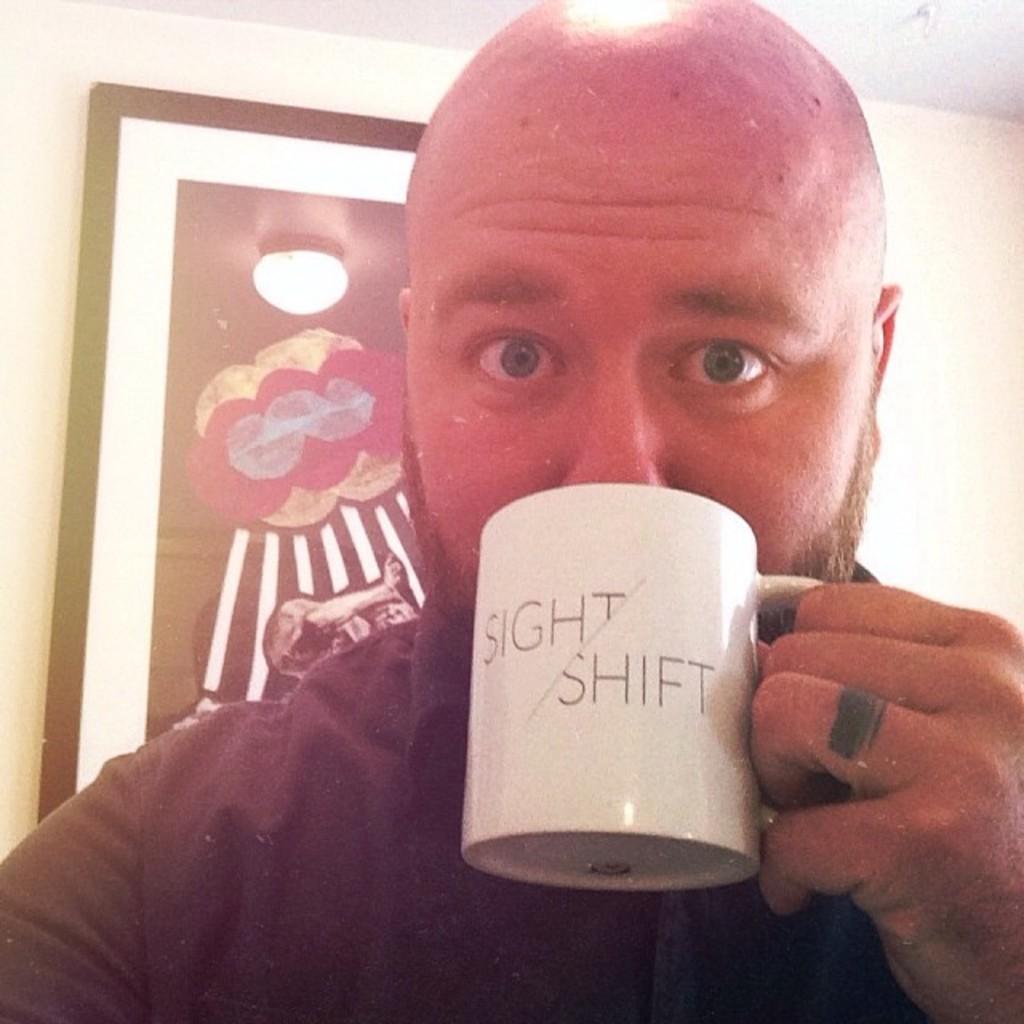What two words are on his cup?
Ensure brevity in your answer.  Sight shift. Which letters are intersected by the diagonal line?
Your answer should be very brief. T s. 